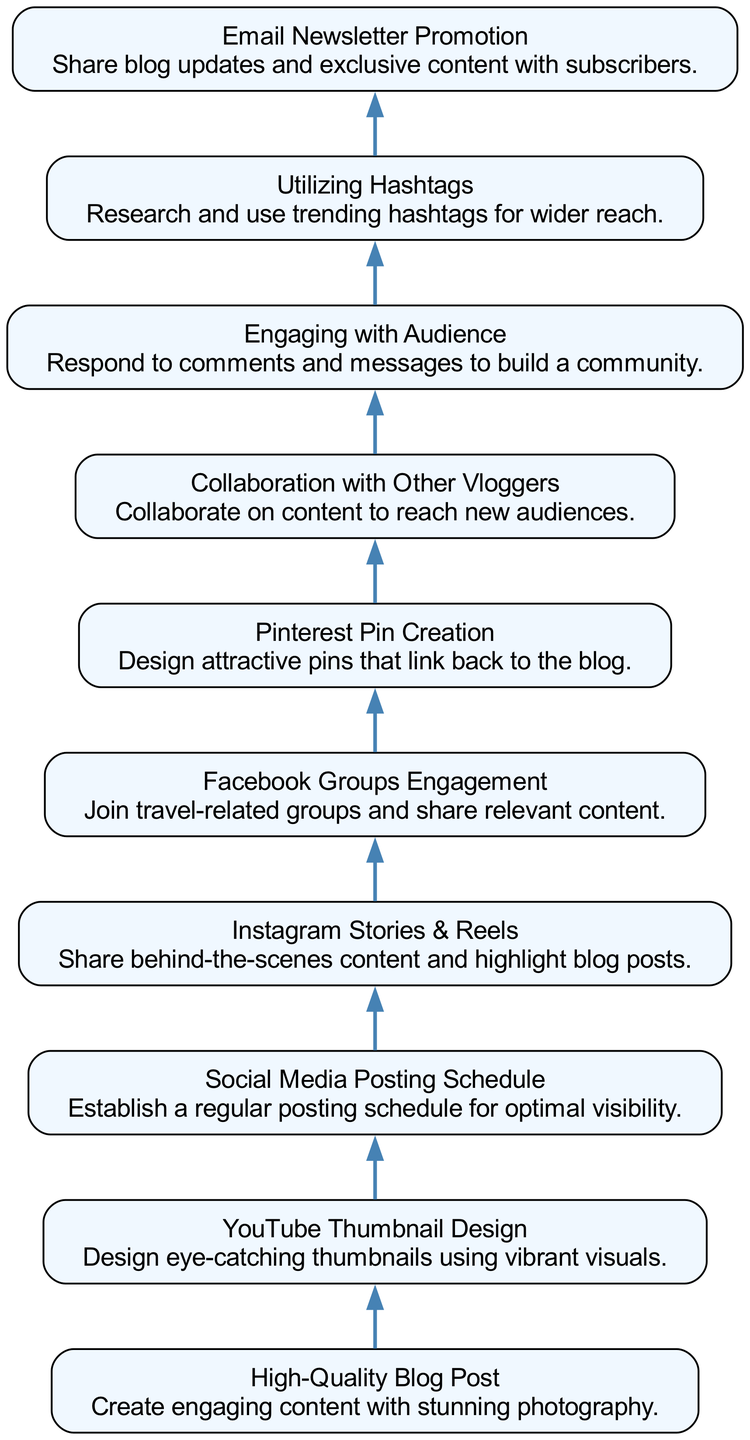What is the first node in the diagram? The first node in the bottom-up flow chart is "High-Quality Blog Post." This can be identified as it is positioned at the very bottom of the diagram, indicating it is the starting point of the flow.
Answer: High-Quality Blog Post How many nodes are present in the diagram? There are ten nodes represented in the diagram. This can be verified by counting the distinct elements listed in the data provided.
Answer: 10 What does the second node suggest? The second node is "YouTube Thumbnail Design," which suggests that after creating a blog post, the next step is to design thumbnails for YouTube using vibrant visuals. This is conveyed by its position flowing directly from the first node.
Answer: YouTube Thumbnail Design Which node comes immediately after "Social Media Posting Schedule"? "Instagram Stories & Reels" comes immediately after "Social Media Posting Schedule." This can be determined by following the directed edges connecting the nodes sequentially in the diagram.
Answer: Instagram Stories & Reels How does "Collaboration with Other Vloggers" connect to the rest of the diagram? "Collaboration with Other Vloggers" connects to the flow by leading to the engagement strategies that enhance audience reach. It represents an essential strategy to expand visibility, linking back to multiple engagement tactics.
Answer: It enhances visibility What is the relationship between "Utilizing Hashtags" and "Engaging with Audience"? "Utilizing Hashtags" and "Engaging with Audience" are connected in that both strategies are aimed at maximizing audience engagement and promoting content effectively. They are separate nodes, but they both contribute to increasing the blog's overall reach.
Answer: Both strategies maximize engagement Which node provides a strategy for visual content promotion? "Pinterest Pin Creation" provides a strategy for visual content promotion, as it specifically focuses on designing attractive pins that link back to the blog. This indicates its role in enhancing visibility through visual platforms.
Answer: Pinterest Pin Creation What is the final node in the diagram? The final node in the diagram is "Email Newsletter Promotion." This represents the last step in the flow, suggesting that after all engagement strategies, updates and exclusive content should be shared with subscribers through email, completing the cycle.
Answer: Email Newsletter Promotion Which nodes emphasize interaction with the audience? "Engaging with Audience" and "Facebook Groups Engagement" emphasize interaction with the audience. Both nodes focus on strategies to create engagement and community building through responses and group participation.
Answer: Engaging with Audience, Facebook Groups Engagement 